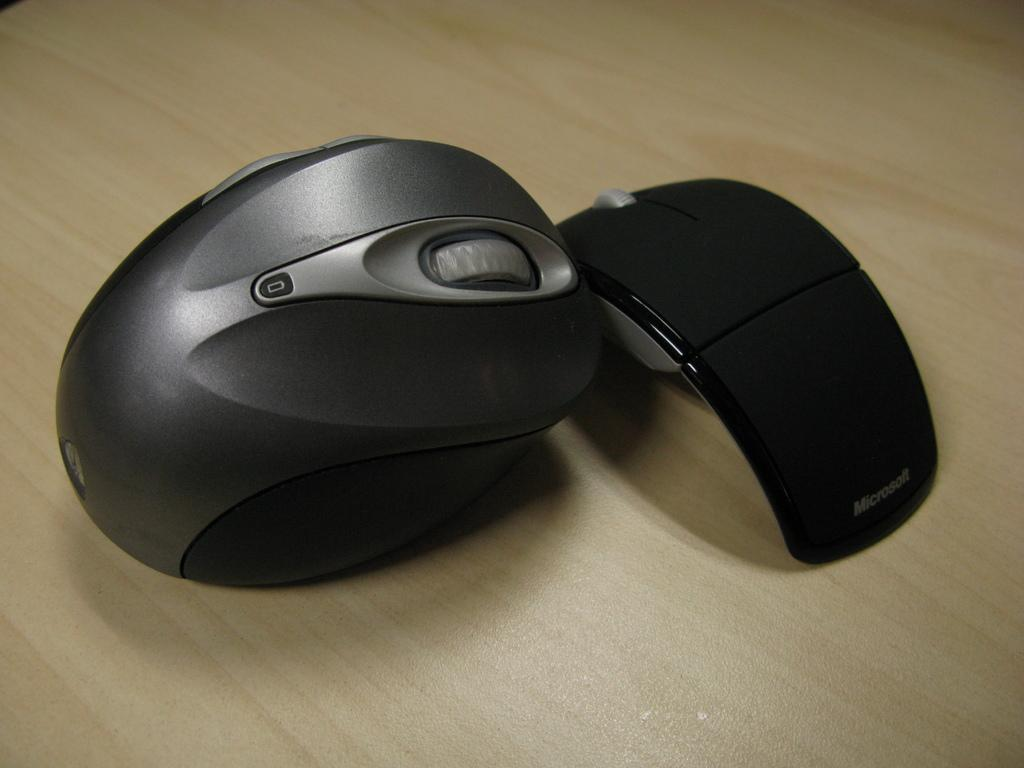What piece of furniture is present at the bottom of the image? There is a table at the bottom of the image. What is located on the table in the image? There are two mouses on the table. What type of snow can be seen in the image? There is no snow present in the image; it features a table with two mouses on it. 